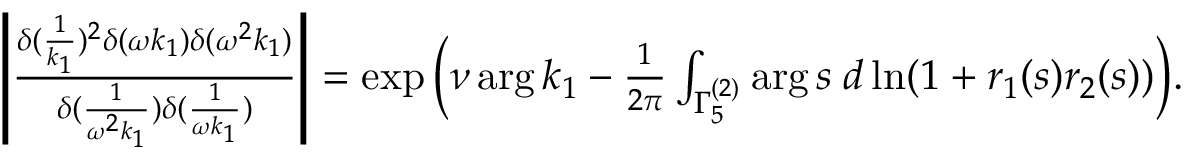Convert formula to latex. <formula><loc_0><loc_0><loc_500><loc_500>\begin{array} { r } { \left | \frac { \delta ( \frac { 1 } { k _ { 1 } } ) ^ { 2 } \delta ( \omega k _ { 1 } ) \delta ( \omega ^ { 2 } k _ { 1 } ) } { \delta ( \frac { 1 } { \omega ^ { 2 } k _ { 1 } } ) \delta ( \frac { 1 } { \omega k _ { 1 } } ) } \right | = \exp \left ( \nu \arg k _ { 1 } - \frac { 1 } { 2 \pi } \int _ { \Gamma _ { 5 } ^ { ( 2 ) } } \arg s \, d \ln ( 1 + r _ { 1 } ( s ) r _ { 2 } ( s ) ) \right ) . } \end{array}</formula> 